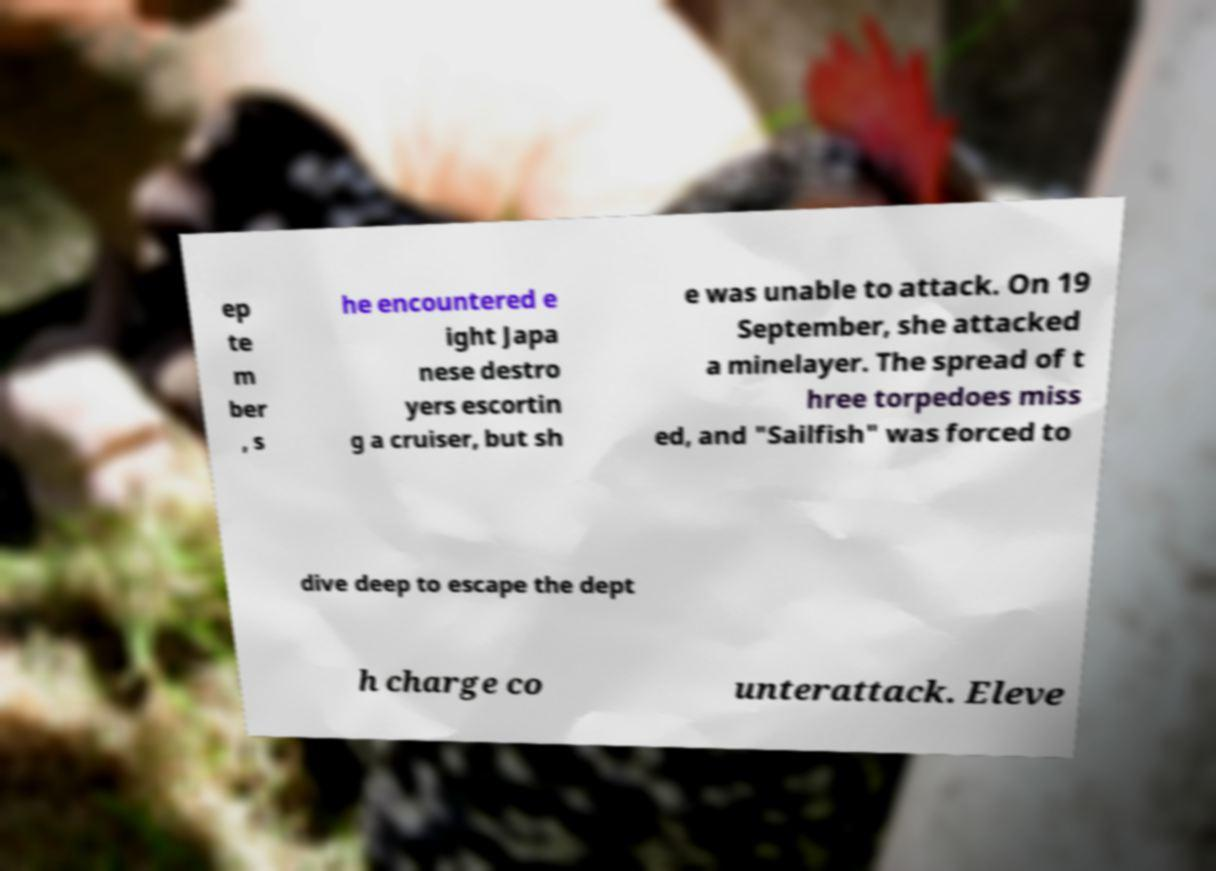Could you extract and type out the text from this image? ep te m ber , s he encountered e ight Japa nese destro yers escortin g a cruiser, but sh e was unable to attack. On 19 September, she attacked a minelayer. The spread of t hree torpedoes miss ed, and "Sailfish" was forced to dive deep to escape the dept h charge co unterattack. Eleve 